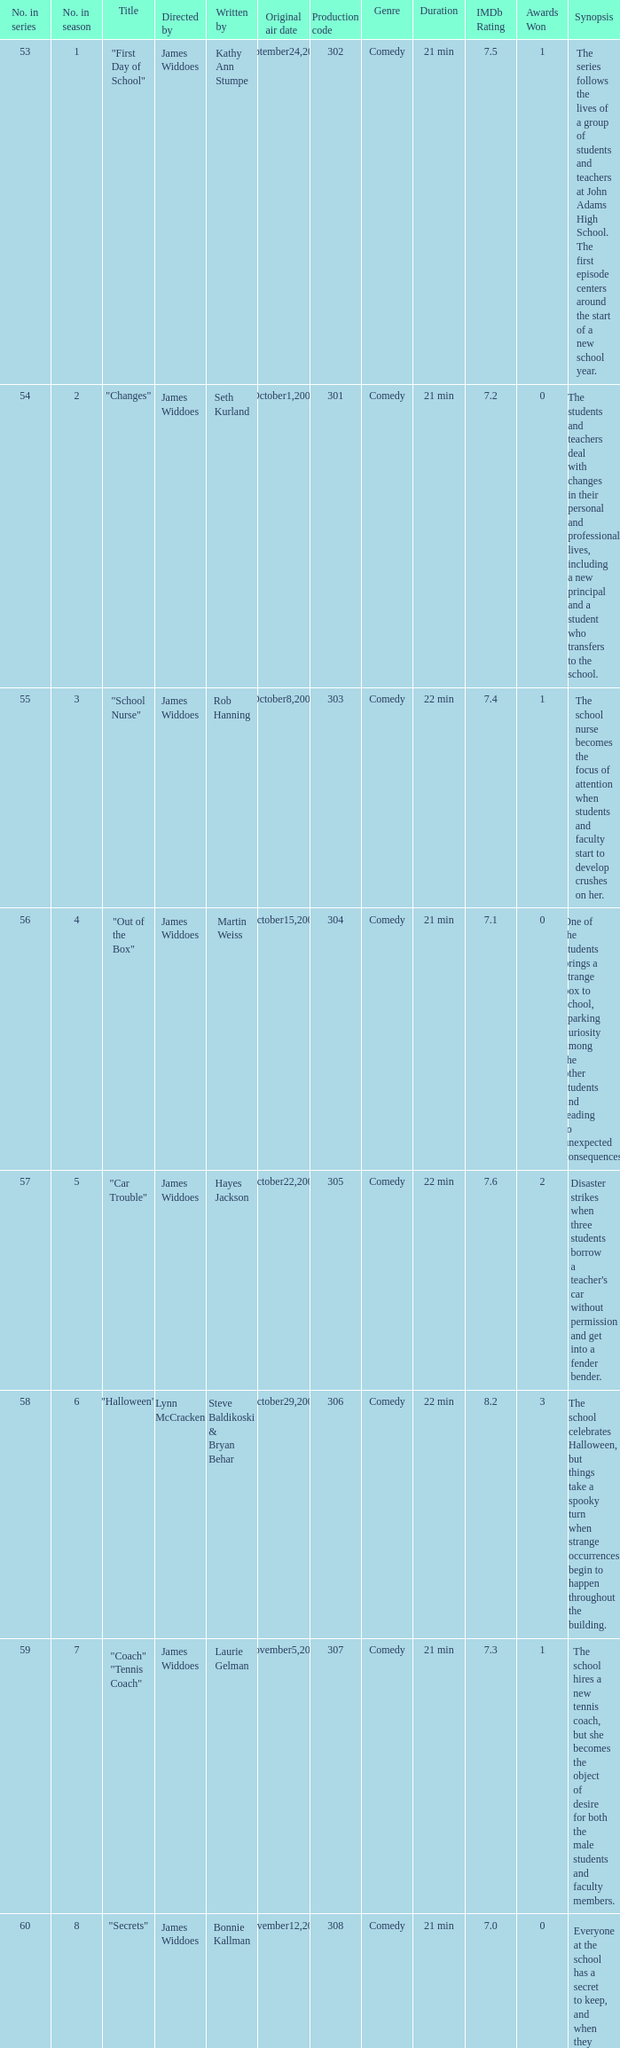What is the production code for episode 3 of the season? 303.0. 